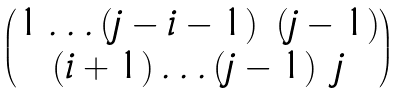<formula> <loc_0><loc_0><loc_500><loc_500>\begin{pmatrix} 1 \dots ( j - i - 1 ) \ ( j - 1 ) \\ ( i + 1 ) \dots ( j - 1 ) \ j \end{pmatrix}</formula> 